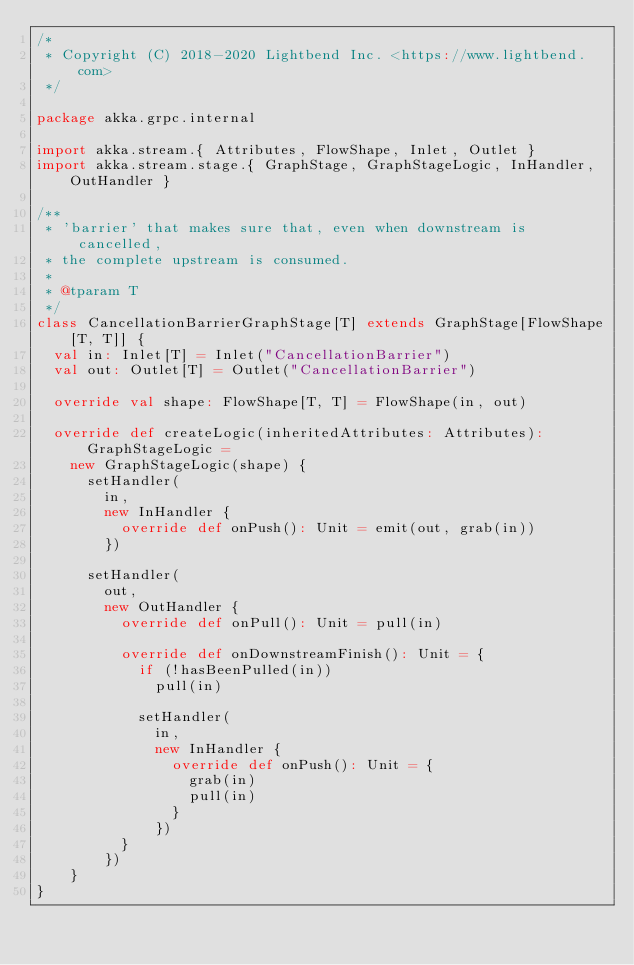<code> <loc_0><loc_0><loc_500><loc_500><_Scala_>/*
 * Copyright (C) 2018-2020 Lightbend Inc. <https://www.lightbend.com>
 */

package akka.grpc.internal

import akka.stream.{ Attributes, FlowShape, Inlet, Outlet }
import akka.stream.stage.{ GraphStage, GraphStageLogic, InHandler, OutHandler }

/**
 * 'barrier' that makes sure that, even when downstream is cancelled,
 * the complete upstream is consumed.
 *
 * @tparam T
 */
class CancellationBarrierGraphStage[T] extends GraphStage[FlowShape[T, T]] {
  val in: Inlet[T] = Inlet("CancellationBarrier")
  val out: Outlet[T] = Outlet("CancellationBarrier")

  override val shape: FlowShape[T, T] = FlowShape(in, out)

  override def createLogic(inheritedAttributes: Attributes): GraphStageLogic =
    new GraphStageLogic(shape) {
      setHandler(
        in,
        new InHandler {
          override def onPush(): Unit = emit(out, grab(in))
        })

      setHandler(
        out,
        new OutHandler {
          override def onPull(): Unit = pull(in)

          override def onDownstreamFinish(): Unit = {
            if (!hasBeenPulled(in))
              pull(in)

            setHandler(
              in,
              new InHandler {
                override def onPush(): Unit = {
                  grab(in)
                  pull(in)
                }
              })
          }
        })
    }
}
</code> 